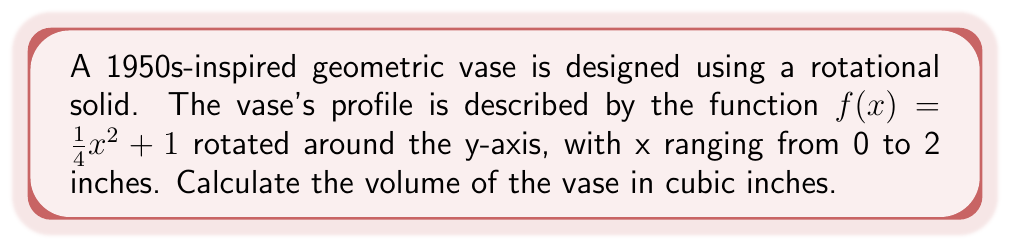Show me your answer to this math problem. To find the volume of this rotational solid, we'll use the washer method:

1) The volume formula for a solid of revolution around the y-axis is:
   $$V = \pi \int_a^b [f(x)]^2 dx$$

2) In this case, $f(x) = \frac{1}{4}x^2 + 1$, $a = 0$, and $b = 2$

3) Substituting into the formula:
   $$V = \pi \int_0^2 (\frac{1}{4}x^2 + 1)^2 dx$$

4) Expanding the squared term:
   $$V = \pi \int_0^2 (\frac{1}{16}x^4 + \frac{1}{2}x^2 + 1) dx$$

5) Integrating:
   $$V = \pi [\frac{1}{80}x^5 + \frac{1}{6}x^3 + x]_0^2$$

6) Evaluating the definite integral:
   $$V = \pi [(\frac{32}{80} + \frac{8}{6} + 2) - (0 + 0 + 0)]$$
   $$V = \pi [\frac{2}{5} + \frac{4}{3} + 2]$$
   $$V = \pi [\frac{12}{15} + \frac{20}{15} + \frac{30}{15}]$$
   $$V = \pi [\frac{62}{15}]$$

7) Simplifying:
   $$V = \frac{62\pi}{15} \approx 13.0053 \text{ cubic inches}$$
Answer: $\frac{62\pi}{15}$ cubic inches 